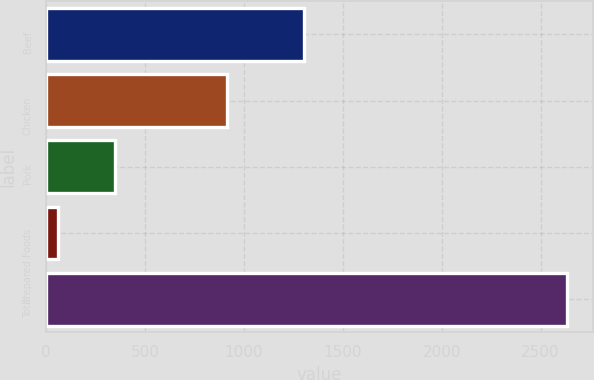Convert chart to OTSL. <chart><loc_0><loc_0><loc_500><loc_500><bar_chart><fcel>Beef<fcel>Chicken<fcel>Pork<fcel>Prepared Foods<fcel>Total<nl><fcel>1306<fcel>917<fcel>350<fcel>60<fcel>2633<nl></chart> 